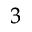<formula> <loc_0><loc_0><loc_500><loc_500>^ { 3 }</formula> 